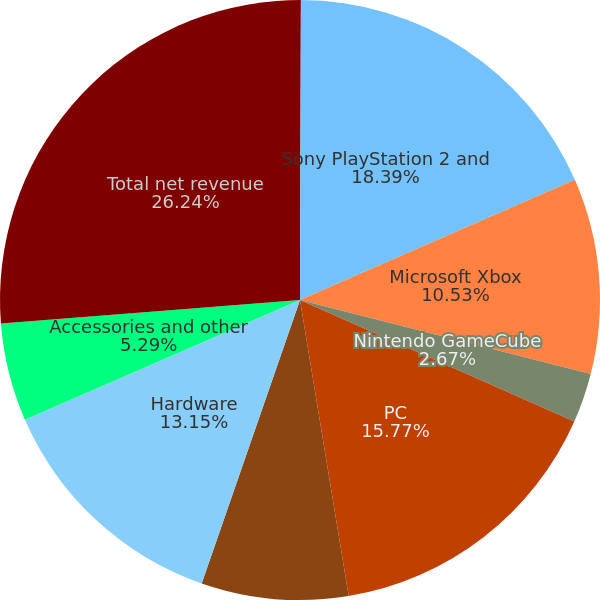<chart> <loc_0><loc_0><loc_500><loc_500><pie_chart><fcel>Net Revenue by Product<fcel>Sony PlayStation 2 and<fcel>Microsoft Xbox<fcel>Nintendo GameCube<fcel>PC<fcel>Nintendo handheld devices<fcel>Hardware<fcel>Accessories and other<fcel>Total net revenue<nl><fcel>0.05%<fcel>18.39%<fcel>10.53%<fcel>2.67%<fcel>15.77%<fcel>7.91%<fcel>13.15%<fcel>5.29%<fcel>26.25%<nl></chart> 